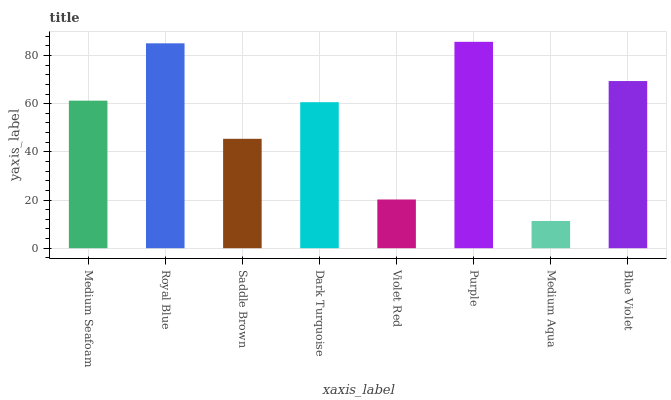Is Medium Aqua the minimum?
Answer yes or no. Yes. Is Purple the maximum?
Answer yes or no. Yes. Is Royal Blue the minimum?
Answer yes or no. No. Is Royal Blue the maximum?
Answer yes or no. No. Is Royal Blue greater than Medium Seafoam?
Answer yes or no. Yes. Is Medium Seafoam less than Royal Blue?
Answer yes or no. Yes. Is Medium Seafoam greater than Royal Blue?
Answer yes or no. No. Is Royal Blue less than Medium Seafoam?
Answer yes or no. No. Is Medium Seafoam the high median?
Answer yes or no. Yes. Is Dark Turquoise the low median?
Answer yes or no. Yes. Is Violet Red the high median?
Answer yes or no. No. Is Medium Aqua the low median?
Answer yes or no. No. 